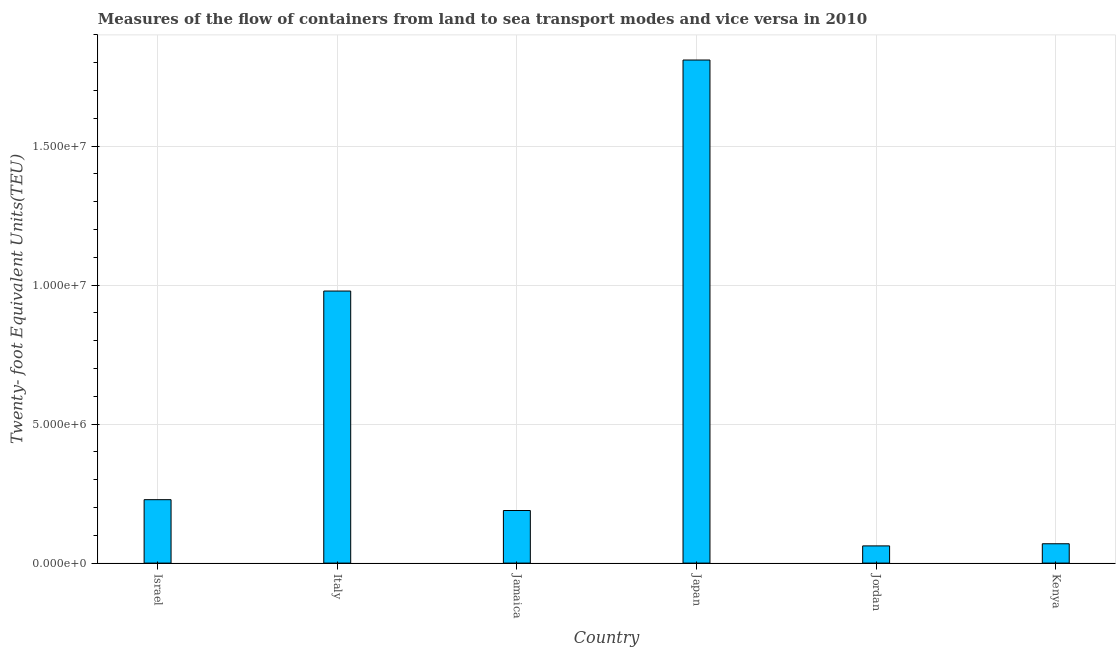Does the graph contain any zero values?
Your answer should be very brief. No. Does the graph contain grids?
Offer a terse response. Yes. What is the title of the graph?
Give a very brief answer. Measures of the flow of containers from land to sea transport modes and vice versa in 2010. What is the label or title of the Y-axis?
Keep it short and to the point. Twenty- foot Equivalent Units(TEU). What is the container port traffic in Italy?
Your response must be concise. 9.79e+06. Across all countries, what is the maximum container port traffic?
Offer a very short reply. 1.81e+07. Across all countries, what is the minimum container port traffic?
Offer a very short reply. 6.19e+05. In which country was the container port traffic maximum?
Provide a short and direct response. Japan. In which country was the container port traffic minimum?
Provide a succinct answer. Jordan. What is the sum of the container port traffic?
Offer a very short reply. 3.34e+07. What is the difference between the container port traffic in Jamaica and Kenya?
Offer a very short reply. 1.20e+06. What is the average container port traffic per country?
Offer a very short reply. 5.56e+06. What is the median container port traffic?
Give a very brief answer. 2.09e+06. What is the ratio of the container port traffic in Israel to that in Jordan?
Offer a terse response. 3.69. Is the difference between the container port traffic in Jamaica and Japan greater than the difference between any two countries?
Your response must be concise. No. What is the difference between the highest and the second highest container port traffic?
Your response must be concise. 8.31e+06. Is the sum of the container port traffic in Israel and Italy greater than the maximum container port traffic across all countries?
Your response must be concise. No. What is the difference between the highest and the lowest container port traffic?
Give a very brief answer. 1.75e+07. How many countries are there in the graph?
Provide a short and direct response. 6. What is the Twenty- foot Equivalent Units(TEU) in Israel?
Provide a short and direct response. 2.28e+06. What is the Twenty- foot Equivalent Units(TEU) of Italy?
Your answer should be very brief. 9.79e+06. What is the Twenty- foot Equivalent Units(TEU) in Jamaica?
Your answer should be compact. 1.89e+06. What is the Twenty- foot Equivalent Units(TEU) of Japan?
Provide a short and direct response. 1.81e+07. What is the Twenty- foot Equivalent Units(TEU) of Jordan?
Provide a short and direct response. 6.19e+05. What is the Twenty- foot Equivalent Units(TEU) in Kenya?
Offer a very short reply. 6.96e+05. What is the difference between the Twenty- foot Equivalent Units(TEU) in Israel and Italy?
Offer a very short reply. -7.51e+06. What is the difference between the Twenty- foot Equivalent Units(TEU) in Israel and Jamaica?
Give a very brief answer. 3.90e+05. What is the difference between the Twenty- foot Equivalent Units(TEU) in Israel and Japan?
Offer a terse response. -1.58e+07. What is the difference between the Twenty- foot Equivalent Units(TEU) in Israel and Jordan?
Make the answer very short. 1.66e+06. What is the difference between the Twenty- foot Equivalent Units(TEU) in Israel and Kenya?
Offer a terse response. 1.59e+06. What is the difference between the Twenty- foot Equivalent Units(TEU) in Italy and Jamaica?
Keep it short and to the point. 7.90e+06. What is the difference between the Twenty- foot Equivalent Units(TEU) in Italy and Japan?
Provide a short and direct response. -8.31e+06. What is the difference between the Twenty- foot Equivalent Units(TEU) in Italy and Jordan?
Your answer should be very brief. 9.17e+06. What is the difference between the Twenty- foot Equivalent Units(TEU) in Italy and Kenya?
Your response must be concise. 9.09e+06. What is the difference between the Twenty- foot Equivalent Units(TEU) in Jamaica and Japan?
Offer a terse response. -1.62e+07. What is the difference between the Twenty- foot Equivalent Units(TEU) in Jamaica and Jordan?
Offer a very short reply. 1.27e+06. What is the difference between the Twenty- foot Equivalent Units(TEU) in Jamaica and Kenya?
Offer a very short reply. 1.20e+06. What is the difference between the Twenty- foot Equivalent Units(TEU) in Japan and Jordan?
Offer a terse response. 1.75e+07. What is the difference between the Twenty- foot Equivalent Units(TEU) in Japan and Kenya?
Give a very brief answer. 1.74e+07. What is the difference between the Twenty- foot Equivalent Units(TEU) in Jordan and Kenya?
Give a very brief answer. -7.70e+04. What is the ratio of the Twenty- foot Equivalent Units(TEU) in Israel to that in Italy?
Offer a very short reply. 0.23. What is the ratio of the Twenty- foot Equivalent Units(TEU) in Israel to that in Jamaica?
Provide a short and direct response. 1.21. What is the ratio of the Twenty- foot Equivalent Units(TEU) in Israel to that in Japan?
Make the answer very short. 0.13. What is the ratio of the Twenty- foot Equivalent Units(TEU) in Israel to that in Jordan?
Your answer should be very brief. 3.69. What is the ratio of the Twenty- foot Equivalent Units(TEU) in Israel to that in Kenya?
Keep it short and to the point. 3.28. What is the ratio of the Twenty- foot Equivalent Units(TEU) in Italy to that in Jamaica?
Provide a short and direct response. 5.17. What is the ratio of the Twenty- foot Equivalent Units(TEU) in Italy to that in Japan?
Provide a succinct answer. 0.54. What is the ratio of the Twenty- foot Equivalent Units(TEU) in Italy to that in Jordan?
Make the answer very short. 15.81. What is the ratio of the Twenty- foot Equivalent Units(TEU) in Italy to that in Kenya?
Ensure brevity in your answer.  14.06. What is the ratio of the Twenty- foot Equivalent Units(TEU) in Jamaica to that in Japan?
Your answer should be compact. 0.1. What is the ratio of the Twenty- foot Equivalent Units(TEU) in Jamaica to that in Jordan?
Provide a short and direct response. 3.06. What is the ratio of the Twenty- foot Equivalent Units(TEU) in Jamaica to that in Kenya?
Your answer should be compact. 2.72. What is the ratio of the Twenty- foot Equivalent Units(TEU) in Japan to that in Jordan?
Provide a short and direct response. 29.24. What is the ratio of the Twenty- foot Equivalent Units(TEU) in Japan to that in Kenya?
Your answer should be compact. 26. What is the ratio of the Twenty- foot Equivalent Units(TEU) in Jordan to that in Kenya?
Your answer should be compact. 0.89. 